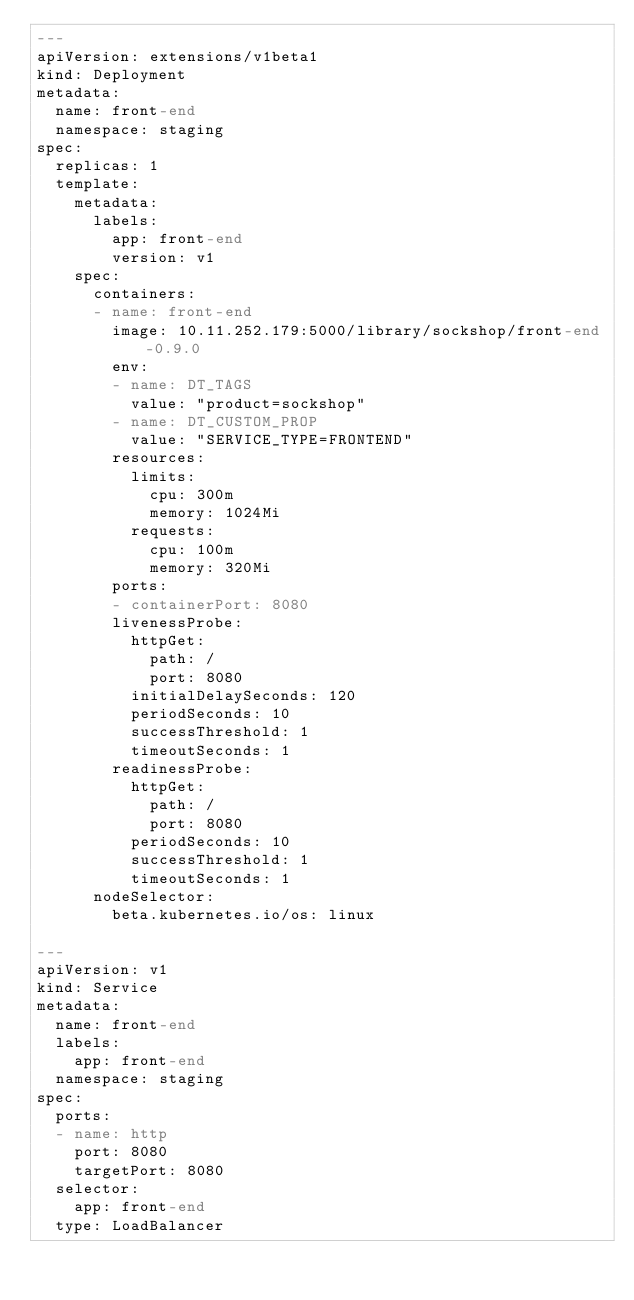<code> <loc_0><loc_0><loc_500><loc_500><_YAML_>---
apiVersion: extensions/v1beta1
kind: Deployment
metadata:
  name: front-end
  namespace: staging
spec:
  replicas: 1
  template:
    metadata:
      labels:
        app: front-end
        version: v1
    spec:
      containers:
      - name: front-end
        image: 10.11.252.179:5000/library/sockshop/front-end-0.9.0
        env: 
        - name: DT_TAGS
          value: "product=sockshop"
        - name: DT_CUSTOM_PROP
          value: "SERVICE_TYPE=FRONTEND"
        resources:
          limits:
            cpu: 300m
            memory: 1024Mi
          requests:
            cpu: 100m
            memory: 320Mi
        ports:
        - containerPort: 8080
        livenessProbe:
          httpGet:
            path: /
            port: 8080
          initialDelaySeconds: 120
          periodSeconds: 10
          successThreshold: 1
          timeoutSeconds: 1
        readinessProbe:
          httpGet:
            path: /
            port: 8080
          periodSeconds: 10
          successThreshold: 1
          timeoutSeconds: 1
      nodeSelector:
        beta.kubernetes.io/os: linux

---
apiVersion: v1
kind: Service
metadata:
  name: front-end
  labels:
    app: front-end
  namespace: staging
spec:
  ports:
  - name: http
    port: 8080
    targetPort: 8080
  selector:
    app: front-end
  type: LoadBalancer
</code> 